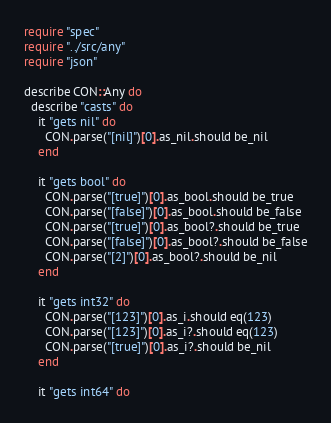<code> <loc_0><loc_0><loc_500><loc_500><_Crystal_>require "spec"
require "../src/any"
require "json"

describe CON::Any do
  describe "casts" do
    it "gets nil" do
      CON.parse("[nil]")[0].as_nil.should be_nil
    end

    it "gets bool" do
      CON.parse("[true]")[0].as_bool.should be_true
      CON.parse("[false]")[0].as_bool.should be_false
      CON.parse("[true]")[0].as_bool?.should be_true
      CON.parse("[false]")[0].as_bool?.should be_false
      CON.parse("[2]")[0].as_bool?.should be_nil
    end

    it "gets int32" do
      CON.parse("[123]")[0].as_i.should eq(123)
      CON.parse("[123]")[0].as_i?.should eq(123)
      CON.parse("[true]")[0].as_i?.should be_nil
    end

    it "gets int64" do</code> 